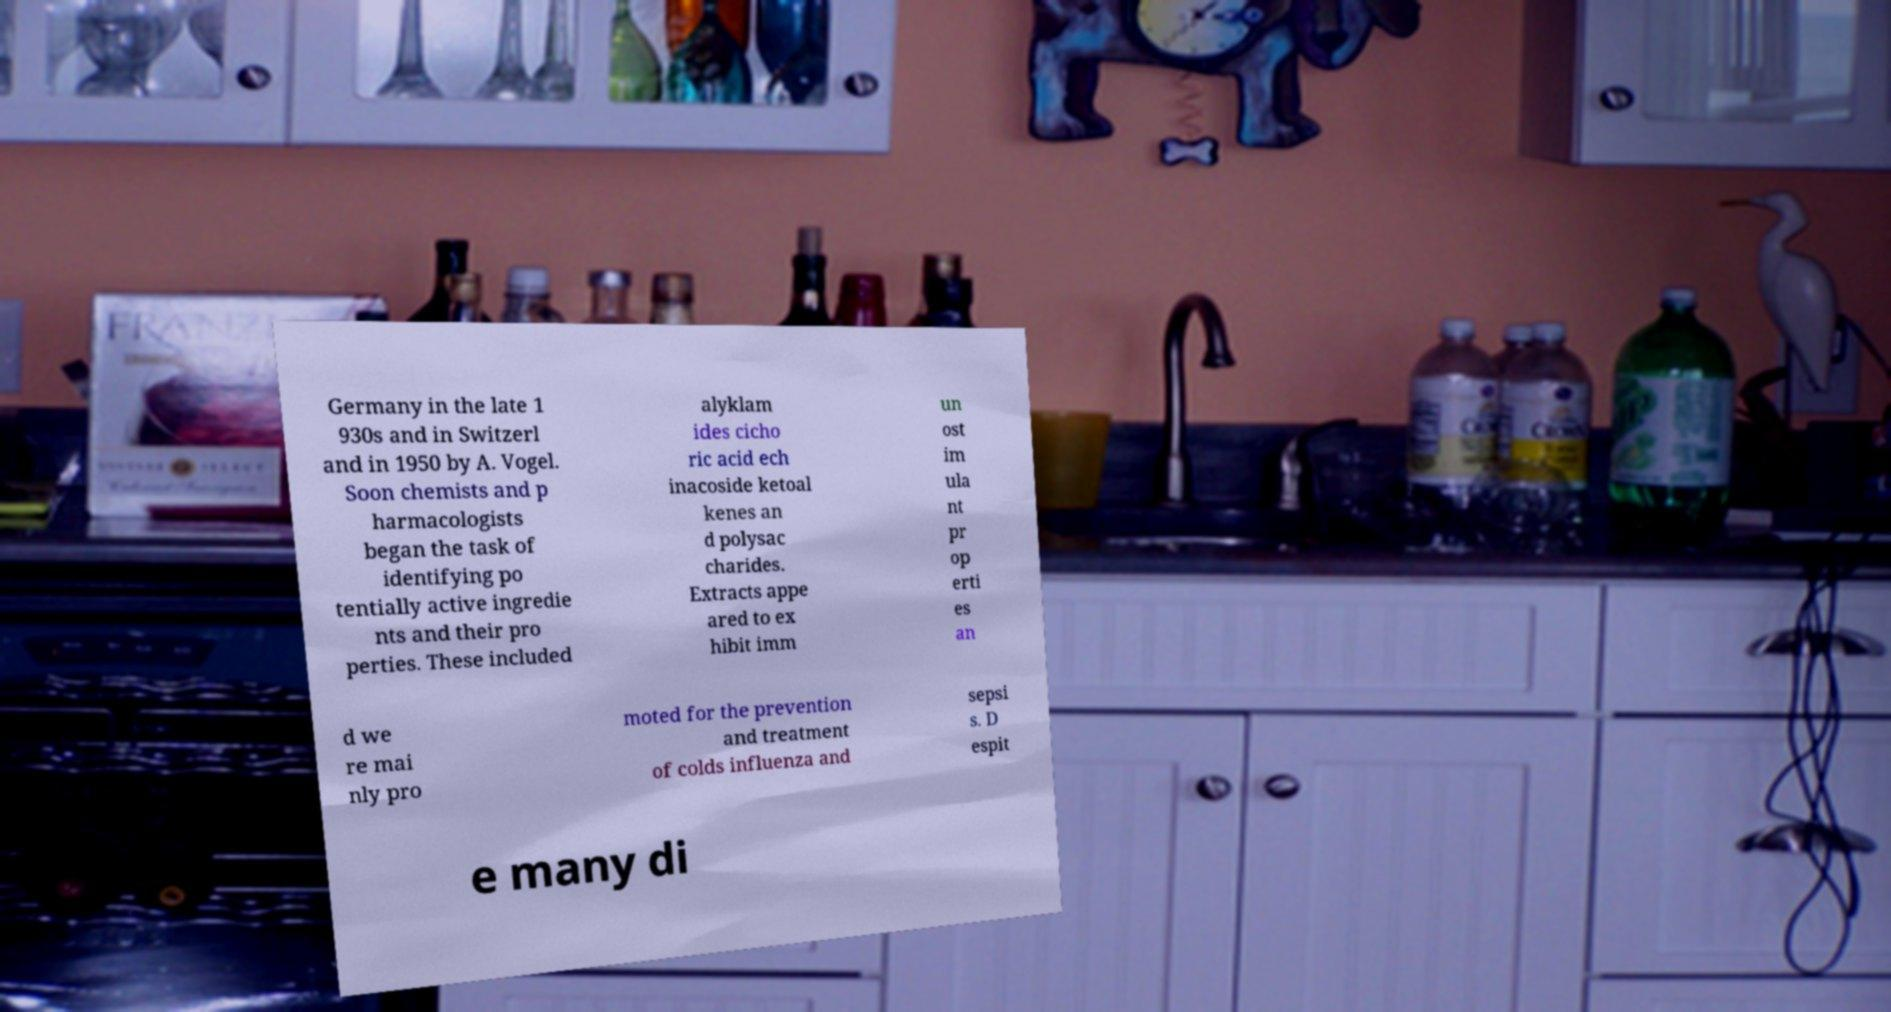I need the written content from this picture converted into text. Can you do that? Germany in the late 1 930s and in Switzerl and in 1950 by A. Vogel. Soon chemists and p harmacologists began the task of identifying po tentially active ingredie nts and their pro perties. These included alyklam ides cicho ric acid ech inacoside ketoal kenes an d polysac charides. Extracts appe ared to ex hibit imm un ost im ula nt pr op erti es an d we re mai nly pro moted for the prevention and treatment of colds influenza and sepsi s. D espit e many di 